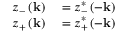<formula> <loc_0><loc_0><loc_500><loc_500>\begin{array} { r l } { z _ { - } \left ( k \right ) } & = z _ { - } ^ { * } \left ( - k \right ) } \\ { z _ { + } \left ( k \right ) } & = z _ { + } ^ { * } \left ( - k \right ) } \end{array}</formula> 